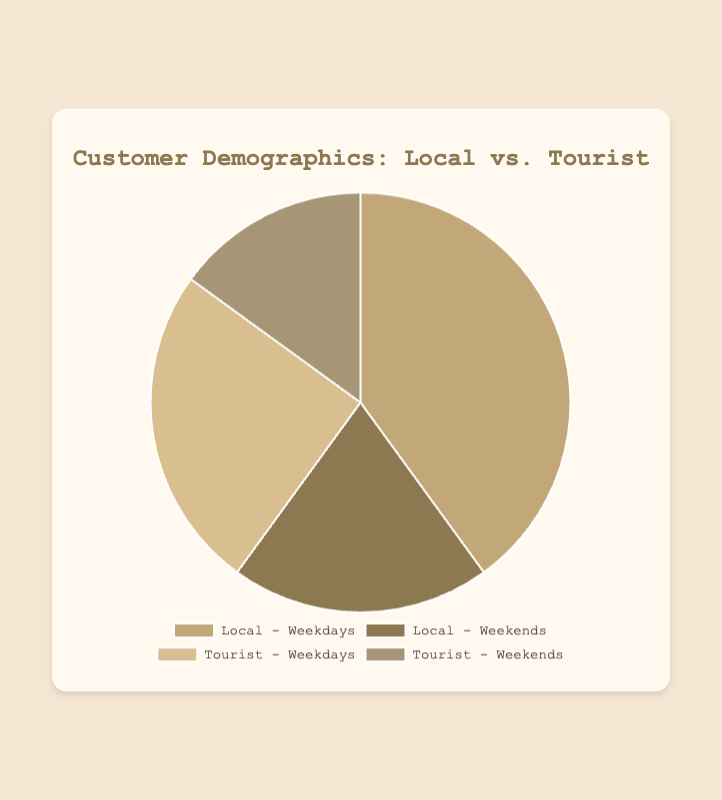Which segment has the highest percentage? The segment "Local - Weekdays" has the highest percentage at 40%, which is higher than any other segment.
Answer: Local - Weekdays Which segment has the lowest percentage? The segment "Tourist - Weekends" has the lowest percentage at 15%, which is lower than any other segment.
Answer: Tourist - Weekends What is the combined percentage of all Local visits (Weekdays and Weekends)? The combined percentage is the sum of "Local - Weekdays" at 40% and "Local - Weekends" at 20%, which equals 60%.
Answer: 60% How much larger is the percentage of "Local - Weekdays" than "Tourist - Weekends"? The percentage of "Local - Weekdays" is 40% and "Tourist - Weekends" is 15%. The difference is 40% - 15% = 25%.
Answer: 25% What is the average percentage of Tourist visits (both Weekdays and Weekends)? The percentages for Tourist visits are 25% for Weekdays and 15% for Weekends. The average is (25% + 15%) / 2 = 20%.
Answer: 20% How much smaller is the percentage of "Tourist - Weekends" compared to "Tourist - Weekdays"? The percentage of "Tourist - Weekends" is 15%, and "Tourist - Weekdays" is 25%. The difference is 25% - 15% = 10%.
Answer: 10% If we combine the percentages of "Local - Weekdays" and "Tourist - Weekdays," what is the total? The total combined percentage for "Local - Weekdays" at 40% and "Tourist - Weekdays" at 25% is 40% + 25% = 65%.
Answer: 65% Which two segments together constitute half of the total percentage? "Local - Weekdays" at 40% and "Tourist - Weekdays" at 25% together make 65%, while "Local - Weekends" at 20% and "Tourist - Weekends" at 15% together make 35%. Therefore, no two segments exactly constitute half of the total percentage, but "Local - Weekdays" (40%) and "Local - Weekends" (20%) together make up 60%, which is closest to half.
Answer: Local - Weekdays and Local - Weekends 